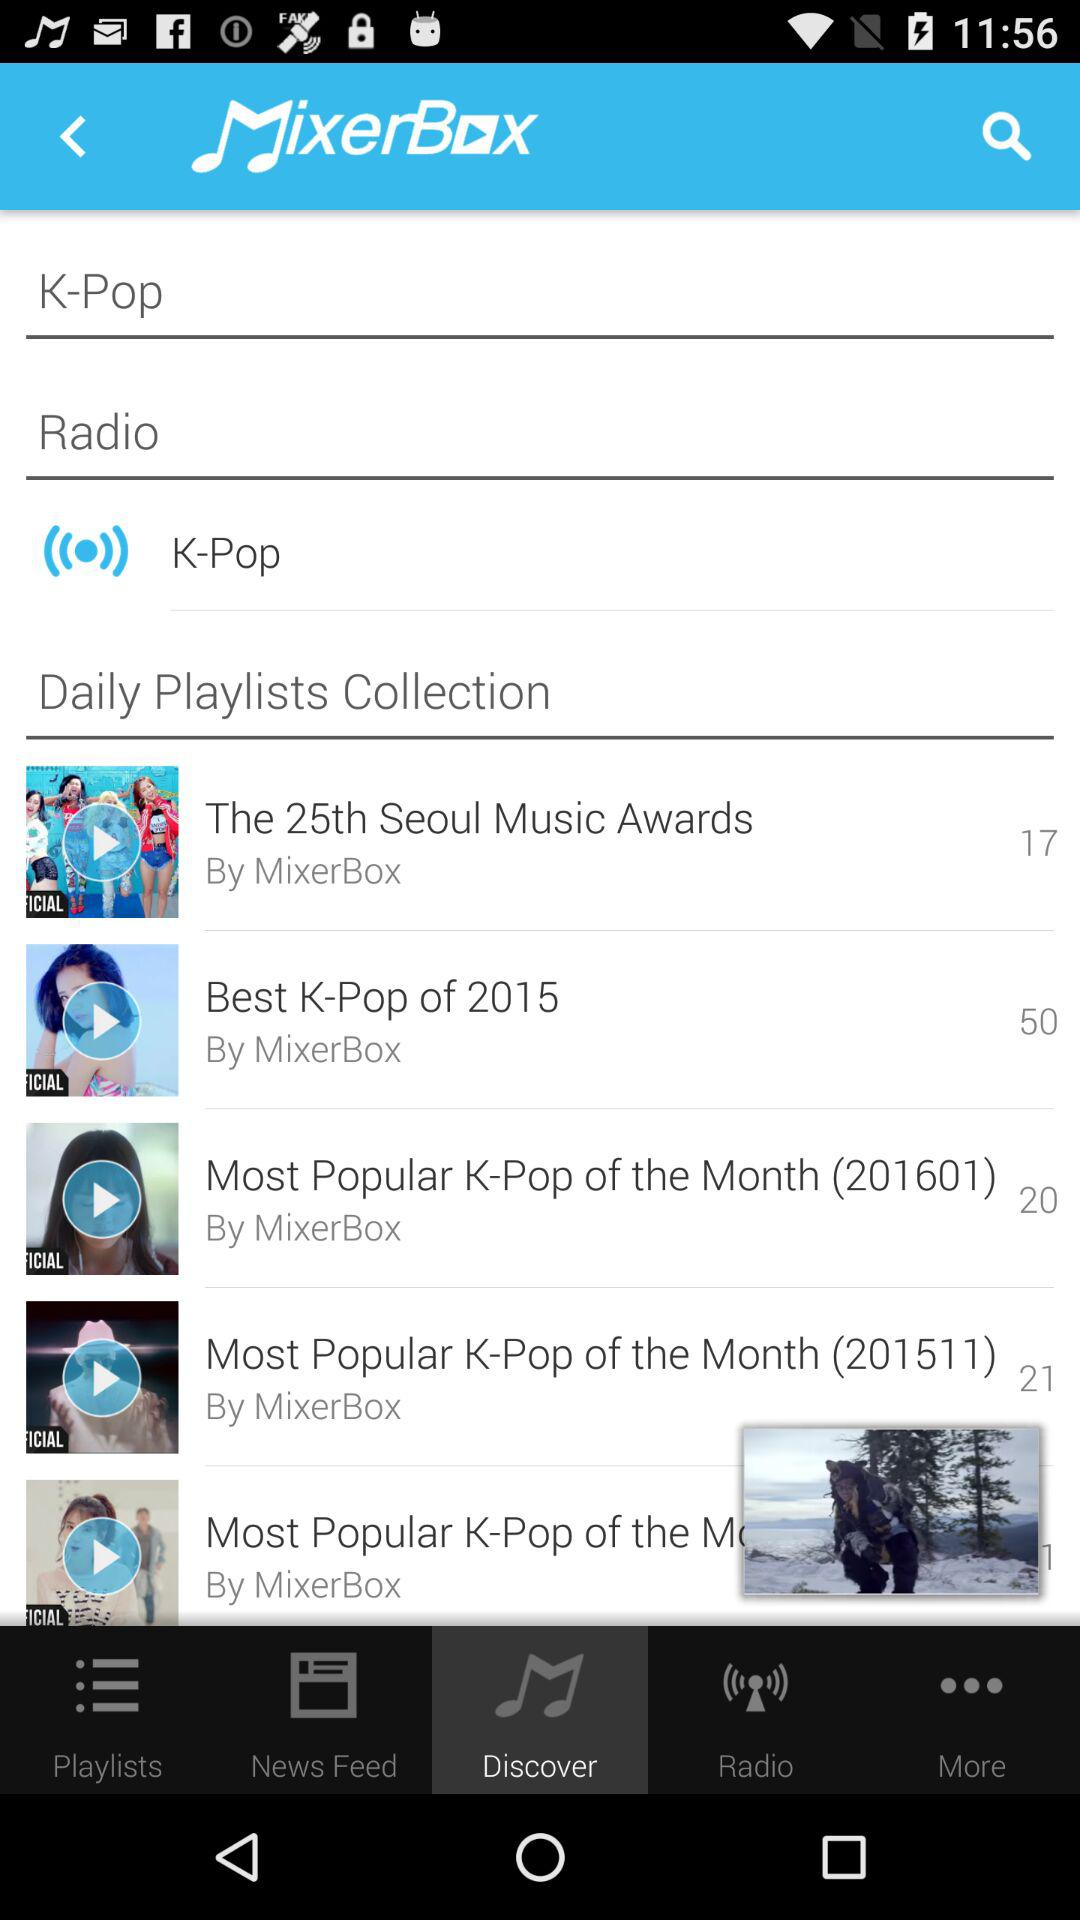What is the name of the creator who created the "Most Popular K-Pop of the Month (201511)" playlist? The name of the creator is "MixerBox". 